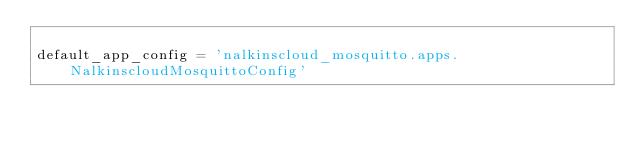<code> <loc_0><loc_0><loc_500><loc_500><_Python_>
default_app_config = 'nalkinscloud_mosquitto.apps.NalkinscloudMosquittoConfig'
</code> 